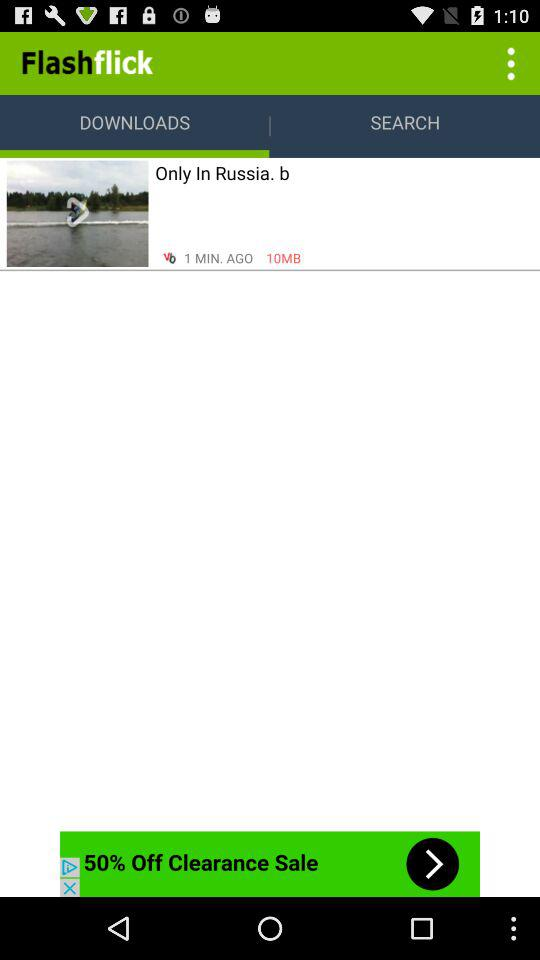What is the download size in MB? The download size in MB is 10. 